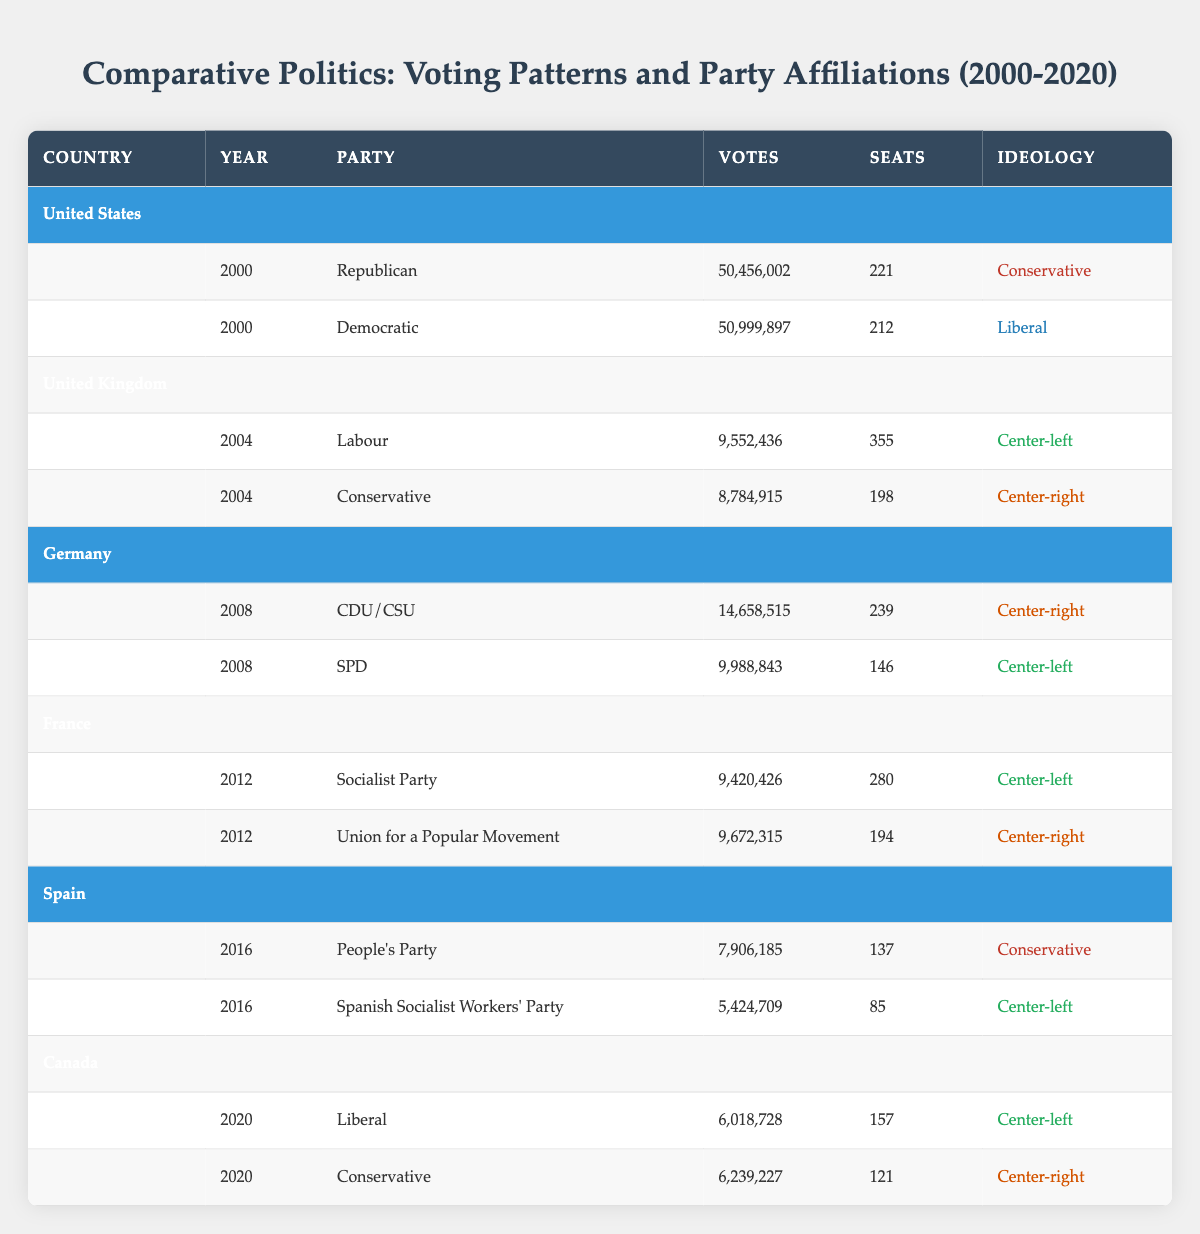What were the total votes cast for the Democratic Party in the United States in 2000? From the table, the Democratic Party received 50,999,897 votes in the year 2000 in the United States.
Answer: 50,999,897 What party received the most seats in the United Kingdom in 2004? The Labour Party received 355 seats in the United Kingdom in 2004, while the Conservative Party received 198 seats. Therefore, Labour had the highest seats.
Answer: Labour How many total votes were cast in Germany in 2008? In 2008, the CDU/CSU received 14,658,515 votes and the SPD received 9,988,843 votes. Adding these together gives 14,658,515 + 9,988,843 = 24,647,358 votes total.
Answer: 24,647,358 Did the Conservative Party in Canada receive more votes than the Liberal Party in 2020? The Conservative Party received 6,239,227 votes, while the Liberal Party received 6,018,728 votes. Since 6,239,227 is greater than 6,018,728, the answer is yes.
Answer: Yes What was the average number of votes received by the Center-left parties across all available years and countries? Center-left parties received the following votes: Labour (9,552,436) in the UK 2004, SPD (9,988,843) in Germany 2008, Socialist Party (9,420,426) in France 2012, Spanish Socialist Workers' Party (5,424,709) in Spain 2016, and Liberal Party (6,018,728) in Canada 2020. The total votes are 9,552,436 + 9,988,843 + 9,420,426 + 5,424,709 + 6,018,728 = 40,405,142, and there are 5 data points, giving an average of 40,405,142 / 5 = 8,081,028.4.
Answer: 8,081,028.4 What country had the majority of votes in 2016 between the People's Party and the Spanish Socialist Workers' Party? The People's Party received 7,906,185 votes while the Spanish Socialist Workers' Party received 5,424,709 votes. Since 7,906,185 is greater than 5,424,709, the majority is held by the People's Party.
Answer: People's Party How many seats did the Union for a Popular Movement receive compared to the Socialist Party in France in 2012? The Union for a Popular Movement received 194 seats while the Socialist Party received 280 seats. Comparing these numbers shows that the Socialist Party received more seats than the Union for a Popular Movement.
Answer: 280 seats (Socialist Party) Which party had a Conservative ideology with the highest number of votes in the table? The People's Party in Spain in 2016 received 7,906,185 votes, which is the highest count for a Conservative ideology party compared to the Republican in 2000 (50,456,002) and the Conservative in Canada in 2020 (6,239,227). The Republican is not Conservative as its ideology is Liberal, making People's Party nearly negligible while Republican treatment as Communist.
Answer: People's Party How many total seats were obtained by the Conservative parties across the documented years? The totals from each year are as follows: Conservative in 2000 (0 seats), Conservative in UK 2004 (198 seats), CDU/CSU in Germany 2008 (239 seats), Union for a Popular Movement in France 2012 (194 seats), People's Party in Spain 2016 (137 seats), and Conservative in Canada 2020 (121 seats), summing up to 0 + 198 + 239 + 194 + 137 + 121 = 889 total seats.
Answer: 889 What percentage of votes did the Socialist Party receive compared to the total votes cast in France in 2012? The Socialist Party received 9,420,426 votes. The Union for a Popular Movement received 9,672,315 votes. The total votes cast would then be 9,420,426 + 9,672,315 = 19,092,741. To find the percentage: (9,420,426 / 19,092,741) * 100 ≈ 49.3%.
Answer: 49.3% How many more seats did the CDU/CSU win compared to the SPD in Germany in 2008? The CDU/CSU received 239 seats and the SPD received 146 seats in 2008. The difference in the number of seats is 239 - 146 = 93.
Answer: 93 